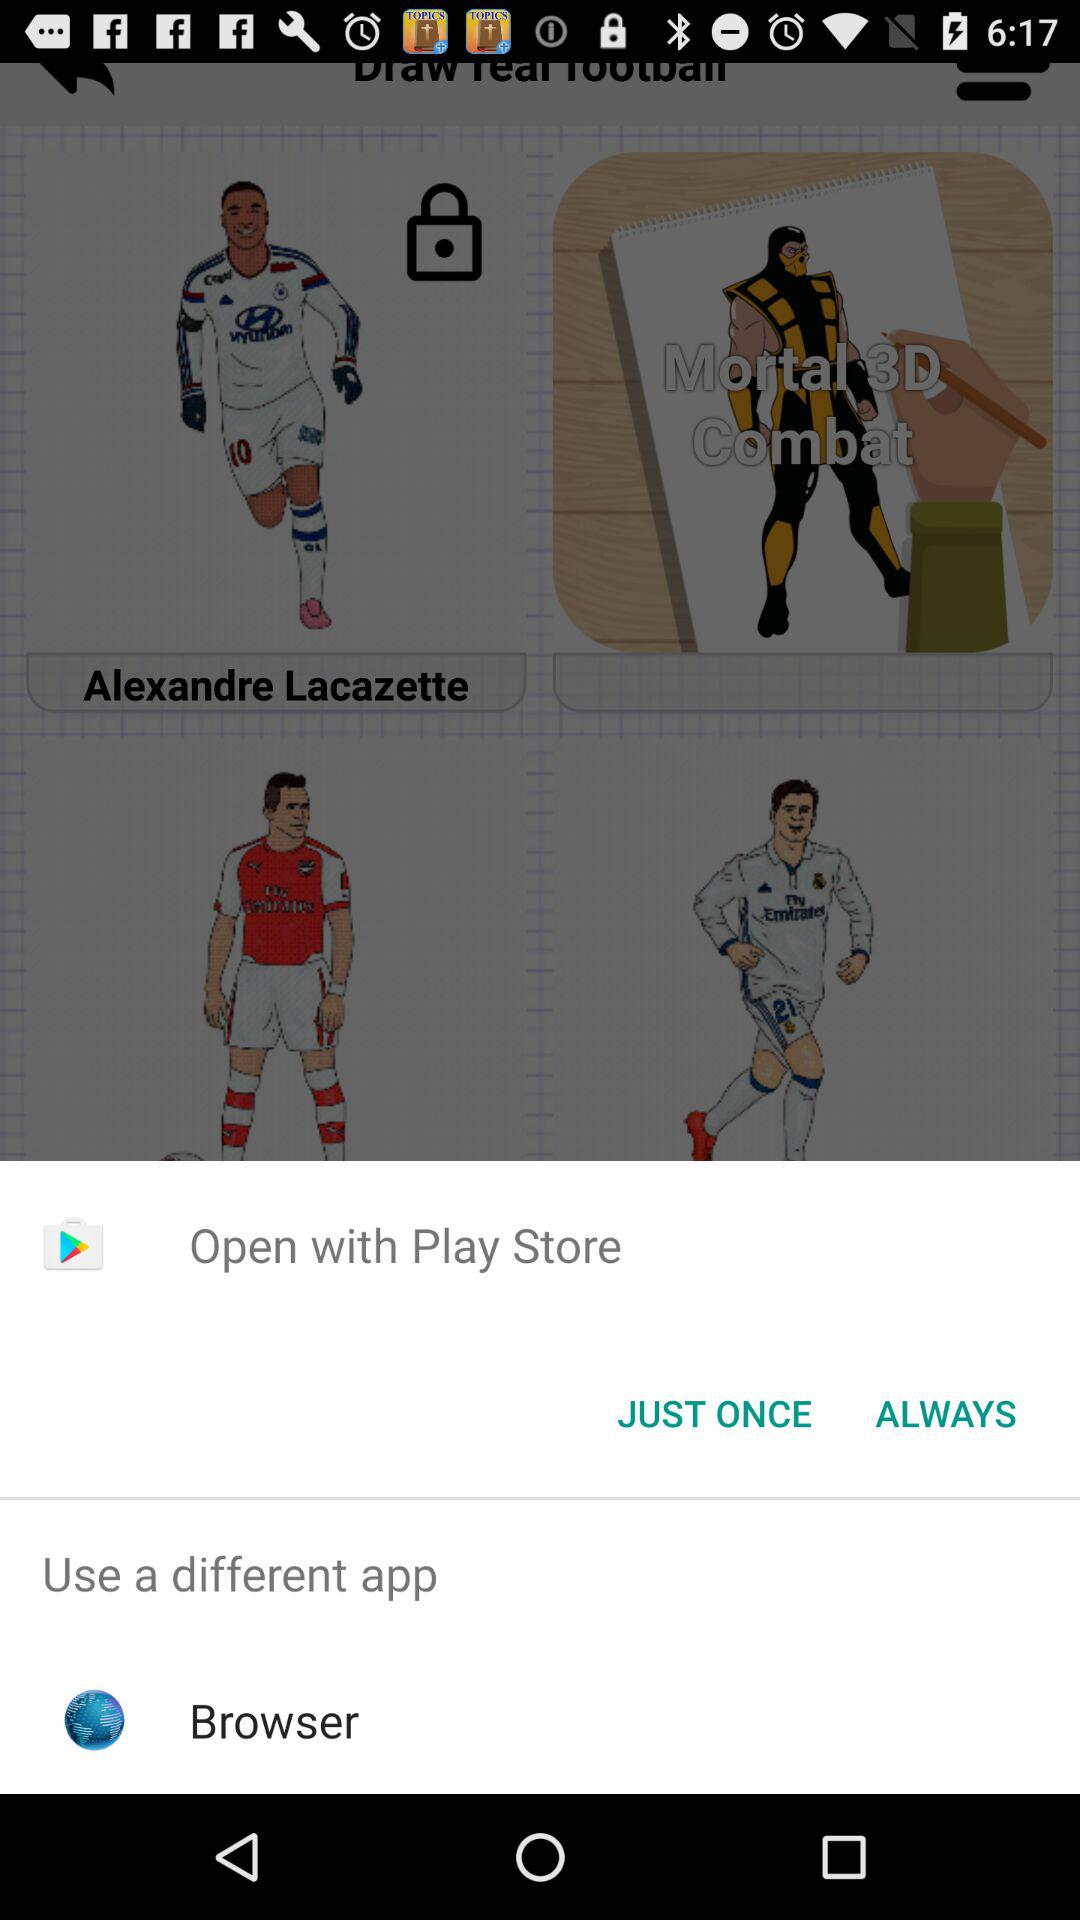Which options are given for opening? The given options are "Play Store" and "Browser". 